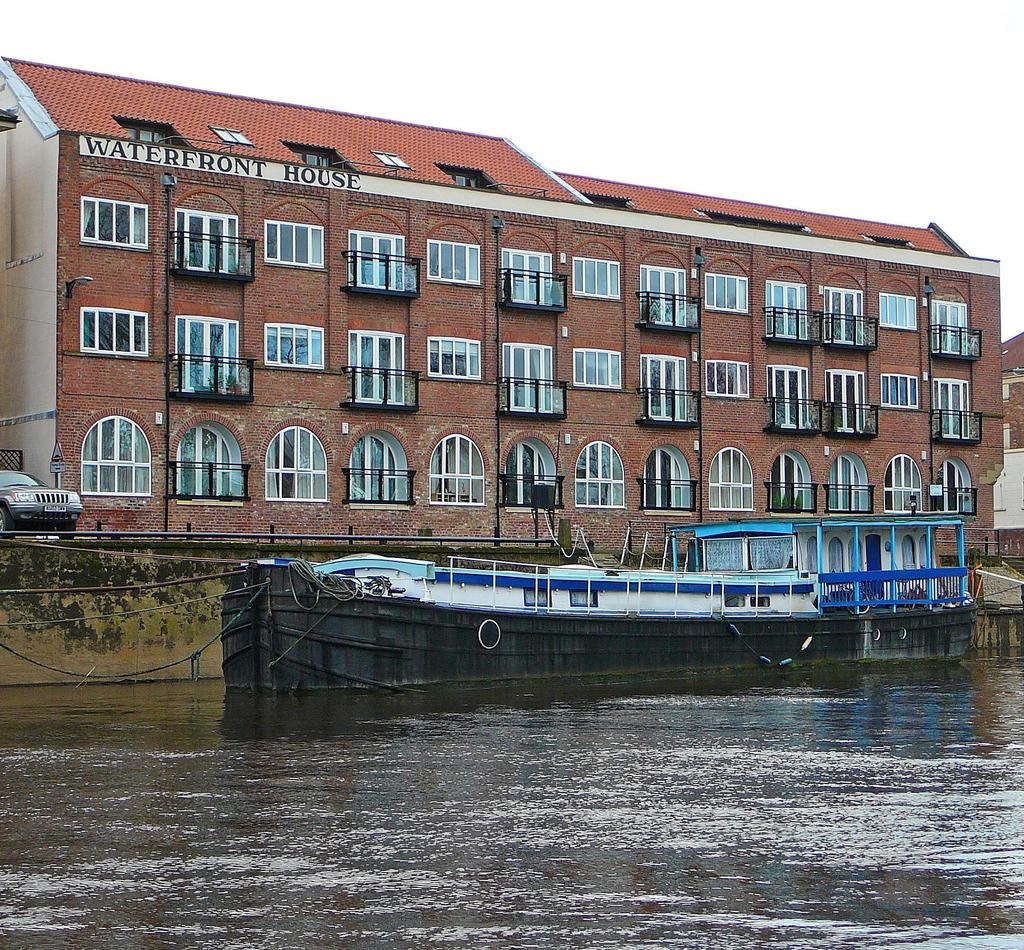What is the main element in the image? There is water in the image. What is on the water? There are boats on the water. What can be seen in the background of the image? There is a car and buildings visible in the background. What part of the natural environment is visible in the image? The sky is visible in the image. What type of bean is being sold at the art gallery in the image? There is no bean or art gallery present in the image. 